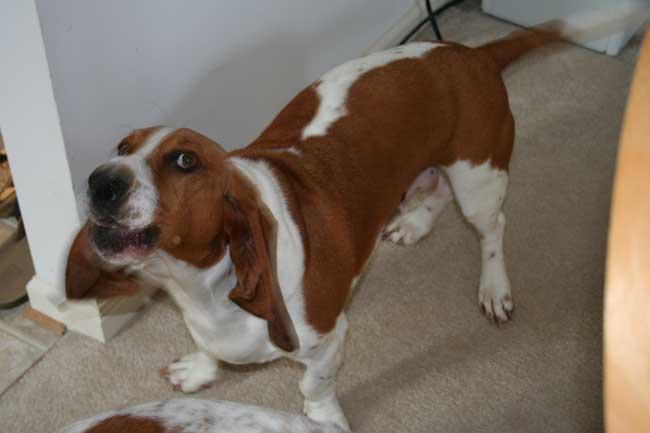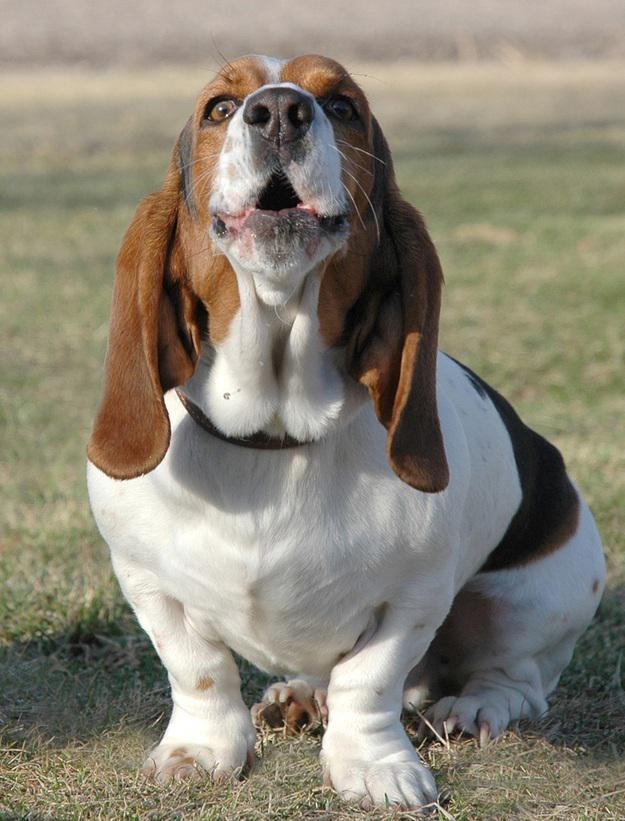The first image is the image on the left, the second image is the image on the right. For the images shown, is this caption "Each image contains exactly one basset hound, with one sitting and one standing." true? Answer yes or no. Yes. 